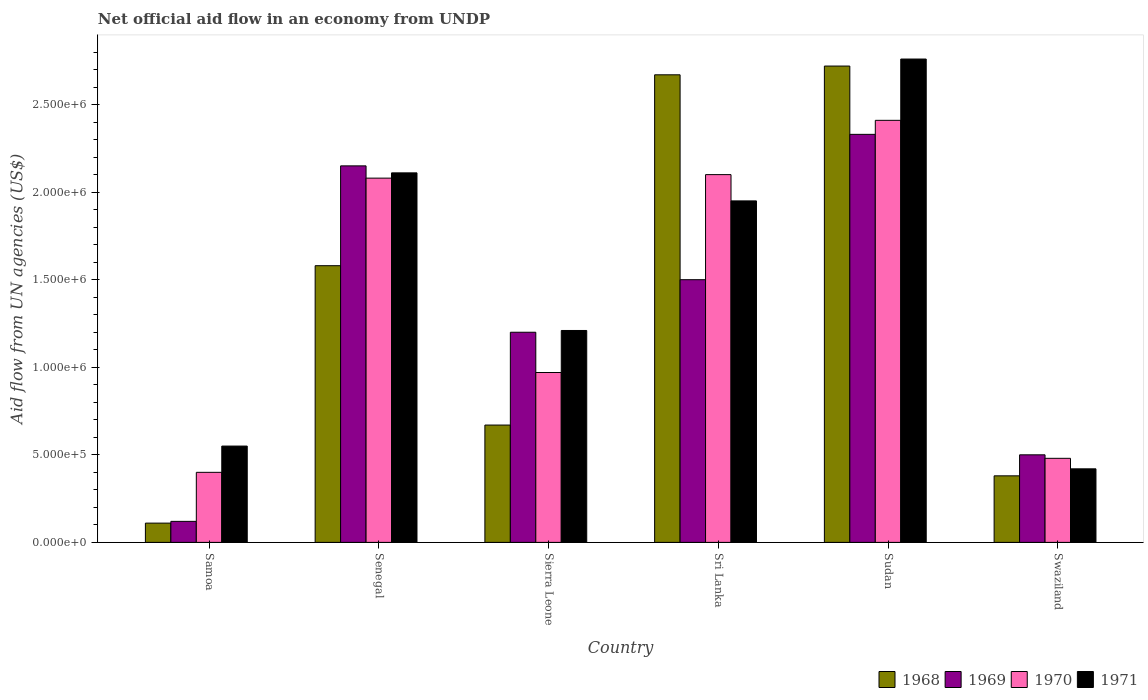How many different coloured bars are there?
Give a very brief answer. 4. Are the number of bars per tick equal to the number of legend labels?
Make the answer very short. Yes. Are the number of bars on each tick of the X-axis equal?
Ensure brevity in your answer.  Yes. How many bars are there on the 4th tick from the right?
Give a very brief answer. 4. What is the label of the 2nd group of bars from the left?
Your answer should be very brief. Senegal. What is the net official aid flow in 1968 in Sri Lanka?
Offer a terse response. 2.67e+06. Across all countries, what is the maximum net official aid flow in 1970?
Your answer should be compact. 2.41e+06. Across all countries, what is the minimum net official aid flow in 1968?
Ensure brevity in your answer.  1.10e+05. In which country was the net official aid flow in 1970 maximum?
Give a very brief answer. Sudan. In which country was the net official aid flow in 1969 minimum?
Your response must be concise. Samoa. What is the total net official aid flow in 1968 in the graph?
Offer a terse response. 8.13e+06. What is the difference between the net official aid flow in 1971 in Senegal and that in Sierra Leone?
Provide a succinct answer. 9.00e+05. What is the average net official aid flow in 1970 per country?
Your answer should be compact. 1.41e+06. What is the difference between the net official aid flow of/in 1971 and net official aid flow of/in 1968 in Sudan?
Offer a terse response. 4.00e+04. What is the ratio of the net official aid flow in 1970 in Senegal to that in Swaziland?
Provide a short and direct response. 4.33. What is the difference between the highest and the second highest net official aid flow in 1968?
Provide a succinct answer. 5.00e+04. What is the difference between the highest and the lowest net official aid flow in 1970?
Provide a succinct answer. 2.01e+06. In how many countries, is the net official aid flow in 1970 greater than the average net official aid flow in 1970 taken over all countries?
Give a very brief answer. 3. Is it the case that in every country, the sum of the net official aid flow in 1968 and net official aid flow in 1970 is greater than the sum of net official aid flow in 1969 and net official aid flow in 1971?
Provide a short and direct response. No. What does the 1st bar from the left in Sudan represents?
Offer a terse response. 1968. What does the 4th bar from the right in Sri Lanka represents?
Offer a terse response. 1968. Are all the bars in the graph horizontal?
Provide a short and direct response. No. How many countries are there in the graph?
Give a very brief answer. 6. What is the difference between two consecutive major ticks on the Y-axis?
Make the answer very short. 5.00e+05. Does the graph contain any zero values?
Offer a very short reply. No. Does the graph contain grids?
Keep it short and to the point. No. Where does the legend appear in the graph?
Keep it short and to the point. Bottom right. What is the title of the graph?
Keep it short and to the point. Net official aid flow in an economy from UNDP. Does "1995" appear as one of the legend labels in the graph?
Give a very brief answer. No. What is the label or title of the Y-axis?
Give a very brief answer. Aid flow from UN agencies (US$). What is the Aid flow from UN agencies (US$) in 1970 in Samoa?
Give a very brief answer. 4.00e+05. What is the Aid flow from UN agencies (US$) in 1968 in Senegal?
Keep it short and to the point. 1.58e+06. What is the Aid flow from UN agencies (US$) of 1969 in Senegal?
Your answer should be compact. 2.15e+06. What is the Aid flow from UN agencies (US$) in 1970 in Senegal?
Provide a succinct answer. 2.08e+06. What is the Aid flow from UN agencies (US$) in 1971 in Senegal?
Your answer should be compact. 2.11e+06. What is the Aid flow from UN agencies (US$) in 1968 in Sierra Leone?
Provide a succinct answer. 6.70e+05. What is the Aid flow from UN agencies (US$) of 1969 in Sierra Leone?
Offer a very short reply. 1.20e+06. What is the Aid flow from UN agencies (US$) of 1970 in Sierra Leone?
Give a very brief answer. 9.70e+05. What is the Aid flow from UN agencies (US$) in 1971 in Sierra Leone?
Provide a succinct answer. 1.21e+06. What is the Aid flow from UN agencies (US$) in 1968 in Sri Lanka?
Offer a terse response. 2.67e+06. What is the Aid flow from UN agencies (US$) in 1969 in Sri Lanka?
Give a very brief answer. 1.50e+06. What is the Aid flow from UN agencies (US$) in 1970 in Sri Lanka?
Your answer should be compact. 2.10e+06. What is the Aid flow from UN agencies (US$) in 1971 in Sri Lanka?
Your response must be concise. 1.95e+06. What is the Aid flow from UN agencies (US$) of 1968 in Sudan?
Make the answer very short. 2.72e+06. What is the Aid flow from UN agencies (US$) of 1969 in Sudan?
Ensure brevity in your answer.  2.33e+06. What is the Aid flow from UN agencies (US$) of 1970 in Sudan?
Offer a terse response. 2.41e+06. What is the Aid flow from UN agencies (US$) in 1971 in Sudan?
Offer a terse response. 2.76e+06. What is the Aid flow from UN agencies (US$) in 1970 in Swaziland?
Give a very brief answer. 4.80e+05. What is the Aid flow from UN agencies (US$) in 1971 in Swaziland?
Keep it short and to the point. 4.20e+05. Across all countries, what is the maximum Aid flow from UN agencies (US$) of 1968?
Your answer should be compact. 2.72e+06. Across all countries, what is the maximum Aid flow from UN agencies (US$) of 1969?
Make the answer very short. 2.33e+06. Across all countries, what is the maximum Aid flow from UN agencies (US$) of 1970?
Keep it short and to the point. 2.41e+06. Across all countries, what is the maximum Aid flow from UN agencies (US$) of 1971?
Offer a very short reply. 2.76e+06. Across all countries, what is the minimum Aid flow from UN agencies (US$) of 1970?
Your answer should be compact. 4.00e+05. Across all countries, what is the minimum Aid flow from UN agencies (US$) in 1971?
Provide a short and direct response. 4.20e+05. What is the total Aid flow from UN agencies (US$) in 1968 in the graph?
Ensure brevity in your answer.  8.13e+06. What is the total Aid flow from UN agencies (US$) of 1969 in the graph?
Your answer should be compact. 7.80e+06. What is the total Aid flow from UN agencies (US$) in 1970 in the graph?
Provide a short and direct response. 8.44e+06. What is the total Aid flow from UN agencies (US$) in 1971 in the graph?
Give a very brief answer. 9.00e+06. What is the difference between the Aid flow from UN agencies (US$) of 1968 in Samoa and that in Senegal?
Keep it short and to the point. -1.47e+06. What is the difference between the Aid flow from UN agencies (US$) of 1969 in Samoa and that in Senegal?
Keep it short and to the point. -2.03e+06. What is the difference between the Aid flow from UN agencies (US$) of 1970 in Samoa and that in Senegal?
Provide a succinct answer. -1.68e+06. What is the difference between the Aid flow from UN agencies (US$) in 1971 in Samoa and that in Senegal?
Your answer should be very brief. -1.56e+06. What is the difference between the Aid flow from UN agencies (US$) of 1968 in Samoa and that in Sierra Leone?
Give a very brief answer. -5.60e+05. What is the difference between the Aid flow from UN agencies (US$) of 1969 in Samoa and that in Sierra Leone?
Give a very brief answer. -1.08e+06. What is the difference between the Aid flow from UN agencies (US$) in 1970 in Samoa and that in Sierra Leone?
Offer a very short reply. -5.70e+05. What is the difference between the Aid flow from UN agencies (US$) in 1971 in Samoa and that in Sierra Leone?
Your answer should be very brief. -6.60e+05. What is the difference between the Aid flow from UN agencies (US$) in 1968 in Samoa and that in Sri Lanka?
Make the answer very short. -2.56e+06. What is the difference between the Aid flow from UN agencies (US$) of 1969 in Samoa and that in Sri Lanka?
Make the answer very short. -1.38e+06. What is the difference between the Aid flow from UN agencies (US$) of 1970 in Samoa and that in Sri Lanka?
Give a very brief answer. -1.70e+06. What is the difference between the Aid flow from UN agencies (US$) of 1971 in Samoa and that in Sri Lanka?
Provide a short and direct response. -1.40e+06. What is the difference between the Aid flow from UN agencies (US$) of 1968 in Samoa and that in Sudan?
Offer a very short reply. -2.61e+06. What is the difference between the Aid flow from UN agencies (US$) in 1969 in Samoa and that in Sudan?
Your response must be concise. -2.21e+06. What is the difference between the Aid flow from UN agencies (US$) of 1970 in Samoa and that in Sudan?
Offer a terse response. -2.01e+06. What is the difference between the Aid flow from UN agencies (US$) of 1971 in Samoa and that in Sudan?
Your answer should be compact. -2.21e+06. What is the difference between the Aid flow from UN agencies (US$) in 1969 in Samoa and that in Swaziland?
Make the answer very short. -3.80e+05. What is the difference between the Aid flow from UN agencies (US$) of 1970 in Samoa and that in Swaziland?
Your answer should be compact. -8.00e+04. What is the difference between the Aid flow from UN agencies (US$) of 1968 in Senegal and that in Sierra Leone?
Your response must be concise. 9.10e+05. What is the difference between the Aid flow from UN agencies (US$) in 1969 in Senegal and that in Sierra Leone?
Offer a terse response. 9.50e+05. What is the difference between the Aid flow from UN agencies (US$) in 1970 in Senegal and that in Sierra Leone?
Provide a short and direct response. 1.11e+06. What is the difference between the Aid flow from UN agencies (US$) in 1971 in Senegal and that in Sierra Leone?
Your answer should be very brief. 9.00e+05. What is the difference between the Aid flow from UN agencies (US$) of 1968 in Senegal and that in Sri Lanka?
Make the answer very short. -1.09e+06. What is the difference between the Aid flow from UN agencies (US$) in 1969 in Senegal and that in Sri Lanka?
Give a very brief answer. 6.50e+05. What is the difference between the Aid flow from UN agencies (US$) of 1970 in Senegal and that in Sri Lanka?
Make the answer very short. -2.00e+04. What is the difference between the Aid flow from UN agencies (US$) of 1968 in Senegal and that in Sudan?
Provide a short and direct response. -1.14e+06. What is the difference between the Aid flow from UN agencies (US$) of 1969 in Senegal and that in Sudan?
Keep it short and to the point. -1.80e+05. What is the difference between the Aid flow from UN agencies (US$) of 1970 in Senegal and that in Sudan?
Your answer should be very brief. -3.30e+05. What is the difference between the Aid flow from UN agencies (US$) of 1971 in Senegal and that in Sudan?
Offer a very short reply. -6.50e+05. What is the difference between the Aid flow from UN agencies (US$) in 1968 in Senegal and that in Swaziland?
Ensure brevity in your answer.  1.20e+06. What is the difference between the Aid flow from UN agencies (US$) in 1969 in Senegal and that in Swaziland?
Keep it short and to the point. 1.65e+06. What is the difference between the Aid flow from UN agencies (US$) in 1970 in Senegal and that in Swaziland?
Provide a succinct answer. 1.60e+06. What is the difference between the Aid flow from UN agencies (US$) of 1971 in Senegal and that in Swaziland?
Make the answer very short. 1.69e+06. What is the difference between the Aid flow from UN agencies (US$) of 1970 in Sierra Leone and that in Sri Lanka?
Provide a short and direct response. -1.13e+06. What is the difference between the Aid flow from UN agencies (US$) in 1971 in Sierra Leone and that in Sri Lanka?
Your response must be concise. -7.40e+05. What is the difference between the Aid flow from UN agencies (US$) of 1968 in Sierra Leone and that in Sudan?
Your answer should be compact. -2.05e+06. What is the difference between the Aid flow from UN agencies (US$) of 1969 in Sierra Leone and that in Sudan?
Provide a short and direct response. -1.13e+06. What is the difference between the Aid flow from UN agencies (US$) of 1970 in Sierra Leone and that in Sudan?
Provide a short and direct response. -1.44e+06. What is the difference between the Aid flow from UN agencies (US$) in 1971 in Sierra Leone and that in Sudan?
Offer a terse response. -1.55e+06. What is the difference between the Aid flow from UN agencies (US$) in 1969 in Sierra Leone and that in Swaziland?
Make the answer very short. 7.00e+05. What is the difference between the Aid flow from UN agencies (US$) of 1971 in Sierra Leone and that in Swaziland?
Give a very brief answer. 7.90e+05. What is the difference between the Aid flow from UN agencies (US$) in 1968 in Sri Lanka and that in Sudan?
Ensure brevity in your answer.  -5.00e+04. What is the difference between the Aid flow from UN agencies (US$) of 1969 in Sri Lanka and that in Sudan?
Your response must be concise. -8.30e+05. What is the difference between the Aid flow from UN agencies (US$) in 1970 in Sri Lanka and that in Sudan?
Make the answer very short. -3.10e+05. What is the difference between the Aid flow from UN agencies (US$) of 1971 in Sri Lanka and that in Sudan?
Offer a terse response. -8.10e+05. What is the difference between the Aid flow from UN agencies (US$) of 1968 in Sri Lanka and that in Swaziland?
Provide a short and direct response. 2.29e+06. What is the difference between the Aid flow from UN agencies (US$) in 1970 in Sri Lanka and that in Swaziland?
Provide a succinct answer. 1.62e+06. What is the difference between the Aid flow from UN agencies (US$) in 1971 in Sri Lanka and that in Swaziland?
Your answer should be compact. 1.53e+06. What is the difference between the Aid flow from UN agencies (US$) in 1968 in Sudan and that in Swaziland?
Your answer should be compact. 2.34e+06. What is the difference between the Aid flow from UN agencies (US$) in 1969 in Sudan and that in Swaziland?
Your response must be concise. 1.83e+06. What is the difference between the Aid flow from UN agencies (US$) of 1970 in Sudan and that in Swaziland?
Your answer should be very brief. 1.93e+06. What is the difference between the Aid flow from UN agencies (US$) of 1971 in Sudan and that in Swaziland?
Offer a terse response. 2.34e+06. What is the difference between the Aid flow from UN agencies (US$) in 1968 in Samoa and the Aid flow from UN agencies (US$) in 1969 in Senegal?
Your response must be concise. -2.04e+06. What is the difference between the Aid flow from UN agencies (US$) of 1968 in Samoa and the Aid flow from UN agencies (US$) of 1970 in Senegal?
Your answer should be very brief. -1.97e+06. What is the difference between the Aid flow from UN agencies (US$) of 1968 in Samoa and the Aid flow from UN agencies (US$) of 1971 in Senegal?
Your answer should be compact. -2.00e+06. What is the difference between the Aid flow from UN agencies (US$) of 1969 in Samoa and the Aid flow from UN agencies (US$) of 1970 in Senegal?
Your answer should be very brief. -1.96e+06. What is the difference between the Aid flow from UN agencies (US$) in 1969 in Samoa and the Aid flow from UN agencies (US$) in 1971 in Senegal?
Offer a terse response. -1.99e+06. What is the difference between the Aid flow from UN agencies (US$) of 1970 in Samoa and the Aid flow from UN agencies (US$) of 1971 in Senegal?
Make the answer very short. -1.71e+06. What is the difference between the Aid flow from UN agencies (US$) in 1968 in Samoa and the Aid flow from UN agencies (US$) in 1969 in Sierra Leone?
Your response must be concise. -1.09e+06. What is the difference between the Aid flow from UN agencies (US$) of 1968 in Samoa and the Aid flow from UN agencies (US$) of 1970 in Sierra Leone?
Provide a succinct answer. -8.60e+05. What is the difference between the Aid flow from UN agencies (US$) in 1968 in Samoa and the Aid flow from UN agencies (US$) in 1971 in Sierra Leone?
Your answer should be very brief. -1.10e+06. What is the difference between the Aid flow from UN agencies (US$) in 1969 in Samoa and the Aid flow from UN agencies (US$) in 1970 in Sierra Leone?
Keep it short and to the point. -8.50e+05. What is the difference between the Aid flow from UN agencies (US$) in 1969 in Samoa and the Aid flow from UN agencies (US$) in 1971 in Sierra Leone?
Provide a short and direct response. -1.09e+06. What is the difference between the Aid flow from UN agencies (US$) in 1970 in Samoa and the Aid flow from UN agencies (US$) in 1971 in Sierra Leone?
Your response must be concise. -8.10e+05. What is the difference between the Aid flow from UN agencies (US$) of 1968 in Samoa and the Aid flow from UN agencies (US$) of 1969 in Sri Lanka?
Give a very brief answer. -1.39e+06. What is the difference between the Aid flow from UN agencies (US$) of 1968 in Samoa and the Aid flow from UN agencies (US$) of 1970 in Sri Lanka?
Offer a very short reply. -1.99e+06. What is the difference between the Aid flow from UN agencies (US$) in 1968 in Samoa and the Aid flow from UN agencies (US$) in 1971 in Sri Lanka?
Make the answer very short. -1.84e+06. What is the difference between the Aid flow from UN agencies (US$) of 1969 in Samoa and the Aid flow from UN agencies (US$) of 1970 in Sri Lanka?
Ensure brevity in your answer.  -1.98e+06. What is the difference between the Aid flow from UN agencies (US$) of 1969 in Samoa and the Aid flow from UN agencies (US$) of 1971 in Sri Lanka?
Your answer should be compact. -1.83e+06. What is the difference between the Aid flow from UN agencies (US$) in 1970 in Samoa and the Aid flow from UN agencies (US$) in 1971 in Sri Lanka?
Your answer should be very brief. -1.55e+06. What is the difference between the Aid flow from UN agencies (US$) in 1968 in Samoa and the Aid flow from UN agencies (US$) in 1969 in Sudan?
Give a very brief answer. -2.22e+06. What is the difference between the Aid flow from UN agencies (US$) in 1968 in Samoa and the Aid flow from UN agencies (US$) in 1970 in Sudan?
Your answer should be very brief. -2.30e+06. What is the difference between the Aid flow from UN agencies (US$) of 1968 in Samoa and the Aid flow from UN agencies (US$) of 1971 in Sudan?
Make the answer very short. -2.65e+06. What is the difference between the Aid flow from UN agencies (US$) in 1969 in Samoa and the Aid flow from UN agencies (US$) in 1970 in Sudan?
Your response must be concise. -2.29e+06. What is the difference between the Aid flow from UN agencies (US$) of 1969 in Samoa and the Aid flow from UN agencies (US$) of 1971 in Sudan?
Your response must be concise. -2.64e+06. What is the difference between the Aid flow from UN agencies (US$) of 1970 in Samoa and the Aid flow from UN agencies (US$) of 1971 in Sudan?
Your answer should be very brief. -2.36e+06. What is the difference between the Aid flow from UN agencies (US$) in 1968 in Samoa and the Aid flow from UN agencies (US$) in 1969 in Swaziland?
Provide a succinct answer. -3.90e+05. What is the difference between the Aid flow from UN agencies (US$) in 1968 in Samoa and the Aid flow from UN agencies (US$) in 1970 in Swaziland?
Your response must be concise. -3.70e+05. What is the difference between the Aid flow from UN agencies (US$) in 1968 in Samoa and the Aid flow from UN agencies (US$) in 1971 in Swaziland?
Your answer should be very brief. -3.10e+05. What is the difference between the Aid flow from UN agencies (US$) in 1969 in Samoa and the Aid flow from UN agencies (US$) in 1970 in Swaziland?
Your answer should be very brief. -3.60e+05. What is the difference between the Aid flow from UN agencies (US$) of 1970 in Samoa and the Aid flow from UN agencies (US$) of 1971 in Swaziland?
Offer a terse response. -2.00e+04. What is the difference between the Aid flow from UN agencies (US$) of 1968 in Senegal and the Aid flow from UN agencies (US$) of 1969 in Sierra Leone?
Your response must be concise. 3.80e+05. What is the difference between the Aid flow from UN agencies (US$) in 1968 in Senegal and the Aid flow from UN agencies (US$) in 1971 in Sierra Leone?
Keep it short and to the point. 3.70e+05. What is the difference between the Aid flow from UN agencies (US$) in 1969 in Senegal and the Aid flow from UN agencies (US$) in 1970 in Sierra Leone?
Provide a short and direct response. 1.18e+06. What is the difference between the Aid flow from UN agencies (US$) in 1969 in Senegal and the Aid flow from UN agencies (US$) in 1971 in Sierra Leone?
Your answer should be very brief. 9.40e+05. What is the difference between the Aid flow from UN agencies (US$) of 1970 in Senegal and the Aid flow from UN agencies (US$) of 1971 in Sierra Leone?
Your answer should be very brief. 8.70e+05. What is the difference between the Aid flow from UN agencies (US$) of 1968 in Senegal and the Aid flow from UN agencies (US$) of 1970 in Sri Lanka?
Your response must be concise. -5.20e+05. What is the difference between the Aid flow from UN agencies (US$) in 1968 in Senegal and the Aid flow from UN agencies (US$) in 1971 in Sri Lanka?
Offer a terse response. -3.70e+05. What is the difference between the Aid flow from UN agencies (US$) of 1969 in Senegal and the Aid flow from UN agencies (US$) of 1971 in Sri Lanka?
Offer a terse response. 2.00e+05. What is the difference between the Aid flow from UN agencies (US$) of 1970 in Senegal and the Aid flow from UN agencies (US$) of 1971 in Sri Lanka?
Your answer should be compact. 1.30e+05. What is the difference between the Aid flow from UN agencies (US$) in 1968 in Senegal and the Aid flow from UN agencies (US$) in 1969 in Sudan?
Make the answer very short. -7.50e+05. What is the difference between the Aid flow from UN agencies (US$) in 1968 in Senegal and the Aid flow from UN agencies (US$) in 1970 in Sudan?
Your response must be concise. -8.30e+05. What is the difference between the Aid flow from UN agencies (US$) in 1968 in Senegal and the Aid flow from UN agencies (US$) in 1971 in Sudan?
Make the answer very short. -1.18e+06. What is the difference between the Aid flow from UN agencies (US$) of 1969 in Senegal and the Aid flow from UN agencies (US$) of 1970 in Sudan?
Offer a terse response. -2.60e+05. What is the difference between the Aid flow from UN agencies (US$) in 1969 in Senegal and the Aid flow from UN agencies (US$) in 1971 in Sudan?
Your answer should be very brief. -6.10e+05. What is the difference between the Aid flow from UN agencies (US$) in 1970 in Senegal and the Aid flow from UN agencies (US$) in 1971 in Sudan?
Your answer should be very brief. -6.80e+05. What is the difference between the Aid flow from UN agencies (US$) of 1968 in Senegal and the Aid flow from UN agencies (US$) of 1969 in Swaziland?
Give a very brief answer. 1.08e+06. What is the difference between the Aid flow from UN agencies (US$) of 1968 in Senegal and the Aid flow from UN agencies (US$) of 1970 in Swaziland?
Make the answer very short. 1.10e+06. What is the difference between the Aid flow from UN agencies (US$) of 1968 in Senegal and the Aid flow from UN agencies (US$) of 1971 in Swaziland?
Make the answer very short. 1.16e+06. What is the difference between the Aid flow from UN agencies (US$) of 1969 in Senegal and the Aid flow from UN agencies (US$) of 1970 in Swaziland?
Offer a terse response. 1.67e+06. What is the difference between the Aid flow from UN agencies (US$) in 1969 in Senegal and the Aid flow from UN agencies (US$) in 1971 in Swaziland?
Make the answer very short. 1.73e+06. What is the difference between the Aid flow from UN agencies (US$) of 1970 in Senegal and the Aid flow from UN agencies (US$) of 1971 in Swaziland?
Give a very brief answer. 1.66e+06. What is the difference between the Aid flow from UN agencies (US$) of 1968 in Sierra Leone and the Aid flow from UN agencies (US$) of 1969 in Sri Lanka?
Your answer should be compact. -8.30e+05. What is the difference between the Aid flow from UN agencies (US$) in 1968 in Sierra Leone and the Aid flow from UN agencies (US$) in 1970 in Sri Lanka?
Provide a succinct answer. -1.43e+06. What is the difference between the Aid flow from UN agencies (US$) of 1968 in Sierra Leone and the Aid flow from UN agencies (US$) of 1971 in Sri Lanka?
Give a very brief answer. -1.28e+06. What is the difference between the Aid flow from UN agencies (US$) in 1969 in Sierra Leone and the Aid flow from UN agencies (US$) in 1970 in Sri Lanka?
Provide a succinct answer. -9.00e+05. What is the difference between the Aid flow from UN agencies (US$) in 1969 in Sierra Leone and the Aid flow from UN agencies (US$) in 1971 in Sri Lanka?
Your answer should be very brief. -7.50e+05. What is the difference between the Aid flow from UN agencies (US$) of 1970 in Sierra Leone and the Aid flow from UN agencies (US$) of 1971 in Sri Lanka?
Provide a succinct answer. -9.80e+05. What is the difference between the Aid flow from UN agencies (US$) in 1968 in Sierra Leone and the Aid flow from UN agencies (US$) in 1969 in Sudan?
Provide a short and direct response. -1.66e+06. What is the difference between the Aid flow from UN agencies (US$) of 1968 in Sierra Leone and the Aid flow from UN agencies (US$) of 1970 in Sudan?
Make the answer very short. -1.74e+06. What is the difference between the Aid flow from UN agencies (US$) in 1968 in Sierra Leone and the Aid flow from UN agencies (US$) in 1971 in Sudan?
Your response must be concise. -2.09e+06. What is the difference between the Aid flow from UN agencies (US$) in 1969 in Sierra Leone and the Aid flow from UN agencies (US$) in 1970 in Sudan?
Offer a very short reply. -1.21e+06. What is the difference between the Aid flow from UN agencies (US$) in 1969 in Sierra Leone and the Aid flow from UN agencies (US$) in 1971 in Sudan?
Offer a terse response. -1.56e+06. What is the difference between the Aid flow from UN agencies (US$) in 1970 in Sierra Leone and the Aid flow from UN agencies (US$) in 1971 in Sudan?
Keep it short and to the point. -1.79e+06. What is the difference between the Aid flow from UN agencies (US$) in 1968 in Sierra Leone and the Aid flow from UN agencies (US$) in 1969 in Swaziland?
Your answer should be compact. 1.70e+05. What is the difference between the Aid flow from UN agencies (US$) in 1968 in Sierra Leone and the Aid flow from UN agencies (US$) in 1970 in Swaziland?
Offer a terse response. 1.90e+05. What is the difference between the Aid flow from UN agencies (US$) of 1968 in Sierra Leone and the Aid flow from UN agencies (US$) of 1971 in Swaziland?
Provide a short and direct response. 2.50e+05. What is the difference between the Aid flow from UN agencies (US$) in 1969 in Sierra Leone and the Aid flow from UN agencies (US$) in 1970 in Swaziland?
Provide a short and direct response. 7.20e+05. What is the difference between the Aid flow from UN agencies (US$) of 1969 in Sierra Leone and the Aid flow from UN agencies (US$) of 1971 in Swaziland?
Your answer should be compact. 7.80e+05. What is the difference between the Aid flow from UN agencies (US$) of 1970 in Sierra Leone and the Aid flow from UN agencies (US$) of 1971 in Swaziland?
Provide a succinct answer. 5.50e+05. What is the difference between the Aid flow from UN agencies (US$) in 1968 in Sri Lanka and the Aid flow from UN agencies (US$) in 1969 in Sudan?
Give a very brief answer. 3.40e+05. What is the difference between the Aid flow from UN agencies (US$) of 1968 in Sri Lanka and the Aid flow from UN agencies (US$) of 1970 in Sudan?
Give a very brief answer. 2.60e+05. What is the difference between the Aid flow from UN agencies (US$) in 1968 in Sri Lanka and the Aid flow from UN agencies (US$) in 1971 in Sudan?
Offer a very short reply. -9.00e+04. What is the difference between the Aid flow from UN agencies (US$) in 1969 in Sri Lanka and the Aid flow from UN agencies (US$) in 1970 in Sudan?
Make the answer very short. -9.10e+05. What is the difference between the Aid flow from UN agencies (US$) of 1969 in Sri Lanka and the Aid flow from UN agencies (US$) of 1971 in Sudan?
Make the answer very short. -1.26e+06. What is the difference between the Aid flow from UN agencies (US$) in 1970 in Sri Lanka and the Aid flow from UN agencies (US$) in 1971 in Sudan?
Offer a very short reply. -6.60e+05. What is the difference between the Aid flow from UN agencies (US$) of 1968 in Sri Lanka and the Aid flow from UN agencies (US$) of 1969 in Swaziland?
Your answer should be very brief. 2.17e+06. What is the difference between the Aid flow from UN agencies (US$) in 1968 in Sri Lanka and the Aid flow from UN agencies (US$) in 1970 in Swaziland?
Ensure brevity in your answer.  2.19e+06. What is the difference between the Aid flow from UN agencies (US$) in 1968 in Sri Lanka and the Aid flow from UN agencies (US$) in 1971 in Swaziland?
Provide a succinct answer. 2.25e+06. What is the difference between the Aid flow from UN agencies (US$) of 1969 in Sri Lanka and the Aid flow from UN agencies (US$) of 1970 in Swaziland?
Offer a terse response. 1.02e+06. What is the difference between the Aid flow from UN agencies (US$) of 1969 in Sri Lanka and the Aid flow from UN agencies (US$) of 1971 in Swaziland?
Make the answer very short. 1.08e+06. What is the difference between the Aid flow from UN agencies (US$) of 1970 in Sri Lanka and the Aid flow from UN agencies (US$) of 1971 in Swaziland?
Your answer should be very brief. 1.68e+06. What is the difference between the Aid flow from UN agencies (US$) in 1968 in Sudan and the Aid flow from UN agencies (US$) in 1969 in Swaziland?
Make the answer very short. 2.22e+06. What is the difference between the Aid flow from UN agencies (US$) in 1968 in Sudan and the Aid flow from UN agencies (US$) in 1970 in Swaziland?
Ensure brevity in your answer.  2.24e+06. What is the difference between the Aid flow from UN agencies (US$) in 1968 in Sudan and the Aid flow from UN agencies (US$) in 1971 in Swaziland?
Your answer should be compact. 2.30e+06. What is the difference between the Aid flow from UN agencies (US$) of 1969 in Sudan and the Aid flow from UN agencies (US$) of 1970 in Swaziland?
Provide a short and direct response. 1.85e+06. What is the difference between the Aid flow from UN agencies (US$) of 1969 in Sudan and the Aid flow from UN agencies (US$) of 1971 in Swaziland?
Your answer should be very brief. 1.91e+06. What is the difference between the Aid flow from UN agencies (US$) in 1970 in Sudan and the Aid flow from UN agencies (US$) in 1971 in Swaziland?
Your answer should be very brief. 1.99e+06. What is the average Aid flow from UN agencies (US$) of 1968 per country?
Keep it short and to the point. 1.36e+06. What is the average Aid flow from UN agencies (US$) in 1969 per country?
Ensure brevity in your answer.  1.30e+06. What is the average Aid flow from UN agencies (US$) of 1970 per country?
Offer a very short reply. 1.41e+06. What is the average Aid flow from UN agencies (US$) of 1971 per country?
Your answer should be compact. 1.50e+06. What is the difference between the Aid flow from UN agencies (US$) of 1968 and Aid flow from UN agencies (US$) of 1971 in Samoa?
Keep it short and to the point. -4.40e+05. What is the difference between the Aid flow from UN agencies (US$) in 1969 and Aid flow from UN agencies (US$) in 1970 in Samoa?
Your answer should be compact. -2.80e+05. What is the difference between the Aid flow from UN agencies (US$) in 1969 and Aid flow from UN agencies (US$) in 1971 in Samoa?
Keep it short and to the point. -4.30e+05. What is the difference between the Aid flow from UN agencies (US$) in 1970 and Aid flow from UN agencies (US$) in 1971 in Samoa?
Your answer should be very brief. -1.50e+05. What is the difference between the Aid flow from UN agencies (US$) of 1968 and Aid flow from UN agencies (US$) of 1969 in Senegal?
Your answer should be very brief. -5.70e+05. What is the difference between the Aid flow from UN agencies (US$) in 1968 and Aid flow from UN agencies (US$) in 1970 in Senegal?
Provide a short and direct response. -5.00e+05. What is the difference between the Aid flow from UN agencies (US$) of 1968 and Aid flow from UN agencies (US$) of 1971 in Senegal?
Provide a short and direct response. -5.30e+05. What is the difference between the Aid flow from UN agencies (US$) of 1969 and Aid flow from UN agencies (US$) of 1970 in Senegal?
Provide a short and direct response. 7.00e+04. What is the difference between the Aid flow from UN agencies (US$) in 1969 and Aid flow from UN agencies (US$) in 1971 in Senegal?
Your answer should be very brief. 4.00e+04. What is the difference between the Aid flow from UN agencies (US$) in 1970 and Aid flow from UN agencies (US$) in 1971 in Senegal?
Provide a short and direct response. -3.00e+04. What is the difference between the Aid flow from UN agencies (US$) in 1968 and Aid flow from UN agencies (US$) in 1969 in Sierra Leone?
Ensure brevity in your answer.  -5.30e+05. What is the difference between the Aid flow from UN agencies (US$) of 1968 and Aid flow from UN agencies (US$) of 1970 in Sierra Leone?
Your answer should be very brief. -3.00e+05. What is the difference between the Aid flow from UN agencies (US$) of 1968 and Aid flow from UN agencies (US$) of 1971 in Sierra Leone?
Make the answer very short. -5.40e+05. What is the difference between the Aid flow from UN agencies (US$) in 1969 and Aid flow from UN agencies (US$) in 1970 in Sierra Leone?
Your answer should be very brief. 2.30e+05. What is the difference between the Aid flow from UN agencies (US$) of 1969 and Aid flow from UN agencies (US$) of 1971 in Sierra Leone?
Your answer should be compact. -10000. What is the difference between the Aid flow from UN agencies (US$) of 1968 and Aid flow from UN agencies (US$) of 1969 in Sri Lanka?
Make the answer very short. 1.17e+06. What is the difference between the Aid flow from UN agencies (US$) of 1968 and Aid flow from UN agencies (US$) of 1970 in Sri Lanka?
Your response must be concise. 5.70e+05. What is the difference between the Aid flow from UN agencies (US$) in 1968 and Aid flow from UN agencies (US$) in 1971 in Sri Lanka?
Give a very brief answer. 7.20e+05. What is the difference between the Aid flow from UN agencies (US$) of 1969 and Aid flow from UN agencies (US$) of 1970 in Sri Lanka?
Provide a succinct answer. -6.00e+05. What is the difference between the Aid flow from UN agencies (US$) in 1969 and Aid flow from UN agencies (US$) in 1971 in Sri Lanka?
Offer a very short reply. -4.50e+05. What is the difference between the Aid flow from UN agencies (US$) in 1970 and Aid flow from UN agencies (US$) in 1971 in Sri Lanka?
Offer a terse response. 1.50e+05. What is the difference between the Aid flow from UN agencies (US$) of 1968 and Aid flow from UN agencies (US$) of 1969 in Sudan?
Offer a terse response. 3.90e+05. What is the difference between the Aid flow from UN agencies (US$) of 1968 and Aid flow from UN agencies (US$) of 1970 in Sudan?
Provide a succinct answer. 3.10e+05. What is the difference between the Aid flow from UN agencies (US$) of 1968 and Aid flow from UN agencies (US$) of 1971 in Sudan?
Give a very brief answer. -4.00e+04. What is the difference between the Aid flow from UN agencies (US$) in 1969 and Aid flow from UN agencies (US$) in 1971 in Sudan?
Offer a very short reply. -4.30e+05. What is the difference between the Aid flow from UN agencies (US$) in 1970 and Aid flow from UN agencies (US$) in 1971 in Sudan?
Offer a very short reply. -3.50e+05. What is the difference between the Aid flow from UN agencies (US$) in 1968 and Aid flow from UN agencies (US$) in 1969 in Swaziland?
Keep it short and to the point. -1.20e+05. What is the difference between the Aid flow from UN agencies (US$) of 1969 and Aid flow from UN agencies (US$) of 1971 in Swaziland?
Ensure brevity in your answer.  8.00e+04. What is the difference between the Aid flow from UN agencies (US$) in 1970 and Aid flow from UN agencies (US$) in 1971 in Swaziland?
Offer a terse response. 6.00e+04. What is the ratio of the Aid flow from UN agencies (US$) in 1968 in Samoa to that in Senegal?
Provide a short and direct response. 0.07. What is the ratio of the Aid flow from UN agencies (US$) of 1969 in Samoa to that in Senegal?
Ensure brevity in your answer.  0.06. What is the ratio of the Aid flow from UN agencies (US$) of 1970 in Samoa to that in Senegal?
Give a very brief answer. 0.19. What is the ratio of the Aid flow from UN agencies (US$) in 1971 in Samoa to that in Senegal?
Your answer should be very brief. 0.26. What is the ratio of the Aid flow from UN agencies (US$) in 1968 in Samoa to that in Sierra Leone?
Ensure brevity in your answer.  0.16. What is the ratio of the Aid flow from UN agencies (US$) in 1970 in Samoa to that in Sierra Leone?
Provide a short and direct response. 0.41. What is the ratio of the Aid flow from UN agencies (US$) of 1971 in Samoa to that in Sierra Leone?
Ensure brevity in your answer.  0.45. What is the ratio of the Aid flow from UN agencies (US$) of 1968 in Samoa to that in Sri Lanka?
Give a very brief answer. 0.04. What is the ratio of the Aid flow from UN agencies (US$) of 1970 in Samoa to that in Sri Lanka?
Your response must be concise. 0.19. What is the ratio of the Aid flow from UN agencies (US$) of 1971 in Samoa to that in Sri Lanka?
Keep it short and to the point. 0.28. What is the ratio of the Aid flow from UN agencies (US$) in 1968 in Samoa to that in Sudan?
Offer a terse response. 0.04. What is the ratio of the Aid flow from UN agencies (US$) of 1969 in Samoa to that in Sudan?
Make the answer very short. 0.05. What is the ratio of the Aid flow from UN agencies (US$) in 1970 in Samoa to that in Sudan?
Offer a very short reply. 0.17. What is the ratio of the Aid flow from UN agencies (US$) of 1971 in Samoa to that in Sudan?
Offer a very short reply. 0.2. What is the ratio of the Aid flow from UN agencies (US$) in 1968 in Samoa to that in Swaziland?
Your answer should be very brief. 0.29. What is the ratio of the Aid flow from UN agencies (US$) in 1969 in Samoa to that in Swaziland?
Ensure brevity in your answer.  0.24. What is the ratio of the Aid flow from UN agencies (US$) of 1970 in Samoa to that in Swaziland?
Provide a succinct answer. 0.83. What is the ratio of the Aid flow from UN agencies (US$) in 1971 in Samoa to that in Swaziland?
Your answer should be very brief. 1.31. What is the ratio of the Aid flow from UN agencies (US$) in 1968 in Senegal to that in Sierra Leone?
Your answer should be compact. 2.36. What is the ratio of the Aid flow from UN agencies (US$) in 1969 in Senegal to that in Sierra Leone?
Give a very brief answer. 1.79. What is the ratio of the Aid flow from UN agencies (US$) in 1970 in Senegal to that in Sierra Leone?
Your response must be concise. 2.14. What is the ratio of the Aid flow from UN agencies (US$) in 1971 in Senegal to that in Sierra Leone?
Offer a terse response. 1.74. What is the ratio of the Aid flow from UN agencies (US$) of 1968 in Senegal to that in Sri Lanka?
Offer a very short reply. 0.59. What is the ratio of the Aid flow from UN agencies (US$) in 1969 in Senegal to that in Sri Lanka?
Keep it short and to the point. 1.43. What is the ratio of the Aid flow from UN agencies (US$) in 1971 in Senegal to that in Sri Lanka?
Provide a short and direct response. 1.08. What is the ratio of the Aid flow from UN agencies (US$) of 1968 in Senegal to that in Sudan?
Keep it short and to the point. 0.58. What is the ratio of the Aid flow from UN agencies (US$) of 1969 in Senegal to that in Sudan?
Provide a short and direct response. 0.92. What is the ratio of the Aid flow from UN agencies (US$) in 1970 in Senegal to that in Sudan?
Provide a succinct answer. 0.86. What is the ratio of the Aid flow from UN agencies (US$) in 1971 in Senegal to that in Sudan?
Your response must be concise. 0.76. What is the ratio of the Aid flow from UN agencies (US$) in 1968 in Senegal to that in Swaziland?
Provide a succinct answer. 4.16. What is the ratio of the Aid flow from UN agencies (US$) in 1969 in Senegal to that in Swaziland?
Offer a very short reply. 4.3. What is the ratio of the Aid flow from UN agencies (US$) of 1970 in Senegal to that in Swaziland?
Offer a very short reply. 4.33. What is the ratio of the Aid flow from UN agencies (US$) in 1971 in Senegal to that in Swaziland?
Your answer should be very brief. 5.02. What is the ratio of the Aid flow from UN agencies (US$) in 1968 in Sierra Leone to that in Sri Lanka?
Make the answer very short. 0.25. What is the ratio of the Aid flow from UN agencies (US$) of 1969 in Sierra Leone to that in Sri Lanka?
Keep it short and to the point. 0.8. What is the ratio of the Aid flow from UN agencies (US$) of 1970 in Sierra Leone to that in Sri Lanka?
Offer a very short reply. 0.46. What is the ratio of the Aid flow from UN agencies (US$) in 1971 in Sierra Leone to that in Sri Lanka?
Offer a terse response. 0.62. What is the ratio of the Aid flow from UN agencies (US$) of 1968 in Sierra Leone to that in Sudan?
Make the answer very short. 0.25. What is the ratio of the Aid flow from UN agencies (US$) of 1969 in Sierra Leone to that in Sudan?
Give a very brief answer. 0.52. What is the ratio of the Aid flow from UN agencies (US$) in 1970 in Sierra Leone to that in Sudan?
Ensure brevity in your answer.  0.4. What is the ratio of the Aid flow from UN agencies (US$) of 1971 in Sierra Leone to that in Sudan?
Offer a terse response. 0.44. What is the ratio of the Aid flow from UN agencies (US$) in 1968 in Sierra Leone to that in Swaziland?
Offer a terse response. 1.76. What is the ratio of the Aid flow from UN agencies (US$) of 1969 in Sierra Leone to that in Swaziland?
Ensure brevity in your answer.  2.4. What is the ratio of the Aid flow from UN agencies (US$) in 1970 in Sierra Leone to that in Swaziland?
Your answer should be compact. 2.02. What is the ratio of the Aid flow from UN agencies (US$) in 1971 in Sierra Leone to that in Swaziland?
Give a very brief answer. 2.88. What is the ratio of the Aid flow from UN agencies (US$) in 1968 in Sri Lanka to that in Sudan?
Ensure brevity in your answer.  0.98. What is the ratio of the Aid flow from UN agencies (US$) of 1969 in Sri Lanka to that in Sudan?
Your response must be concise. 0.64. What is the ratio of the Aid flow from UN agencies (US$) of 1970 in Sri Lanka to that in Sudan?
Keep it short and to the point. 0.87. What is the ratio of the Aid flow from UN agencies (US$) of 1971 in Sri Lanka to that in Sudan?
Make the answer very short. 0.71. What is the ratio of the Aid flow from UN agencies (US$) of 1968 in Sri Lanka to that in Swaziland?
Make the answer very short. 7.03. What is the ratio of the Aid flow from UN agencies (US$) in 1969 in Sri Lanka to that in Swaziland?
Offer a very short reply. 3. What is the ratio of the Aid flow from UN agencies (US$) of 1970 in Sri Lanka to that in Swaziland?
Give a very brief answer. 4.38. What is the ratio of the Aid flow from UN agencies (US$) in 1971 in Sri Lanka to that in Swaziland?
Your response must be concise. 4.64. What is the ratio of the Aid flow from UN agencies (US$) in 1968 in Sudan to that in Swaziland?
Your response must be concise. 7.16. What is the ratio of the Aid flow from UN agencies (US$) in 1969 in Sudan to that in Swaziland?
Provide a short and direct response. 4.66. What is the ratio of the Aid flow from UN agencies (US$) in 1970 in Sudan to that in Swaziland?
Keep it short and to the point. 5.02. What is the ratio of the Aid flow from UN agencies (US$) of 1971 in Sudan to that in Swaziland?
Your answer should be compact. 6.57. What is the difference between the highest and the second highest Aid flow from UN agencies (US$) in 1968?
Keep it short and to the point. 5.00e+04. What is the difference between the highest and the second highest Aid flow from UN agencies (US$) of 1969?
Ensure brevity in your answer.  1.80e+05. What is the difference between the highest and the second highest Aid flow from UN agencies (US$) of 1971?
Your answer should be compact. 6.50e+05. What is the difference between the highest and the lowest Aid flow from UN agencies (US$) in 1968?
Your answer should be compact. 2.61e+06. What is the difference between the highest and the lowest Aid flow from UN agencies (US$) in 1969?
Your answer should be very brief. 2.21e+06. What is the difference between the highest and the lowest Aid flow from UN agencies (US$) in 1970?
Make the answer very short. 2.01e+06. What is the difference between the highest and the lowest Aid flow from UN agencies (US$) of 1971?
Offer a terse response. 2.34e+06. 